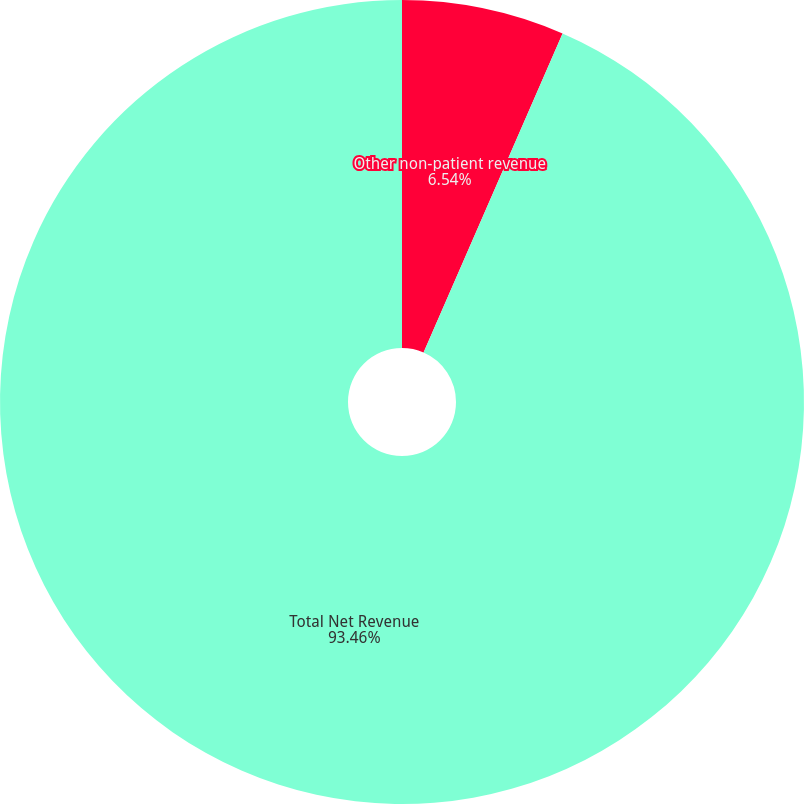<chart> <loc_0><loc_0><loc_500><loc_500><pie_chart><fcel>Other non-patient revenue<fcel>Total Net Revenue<nl><fcel>6.54%<fcel>93.46%<nl></chart> 